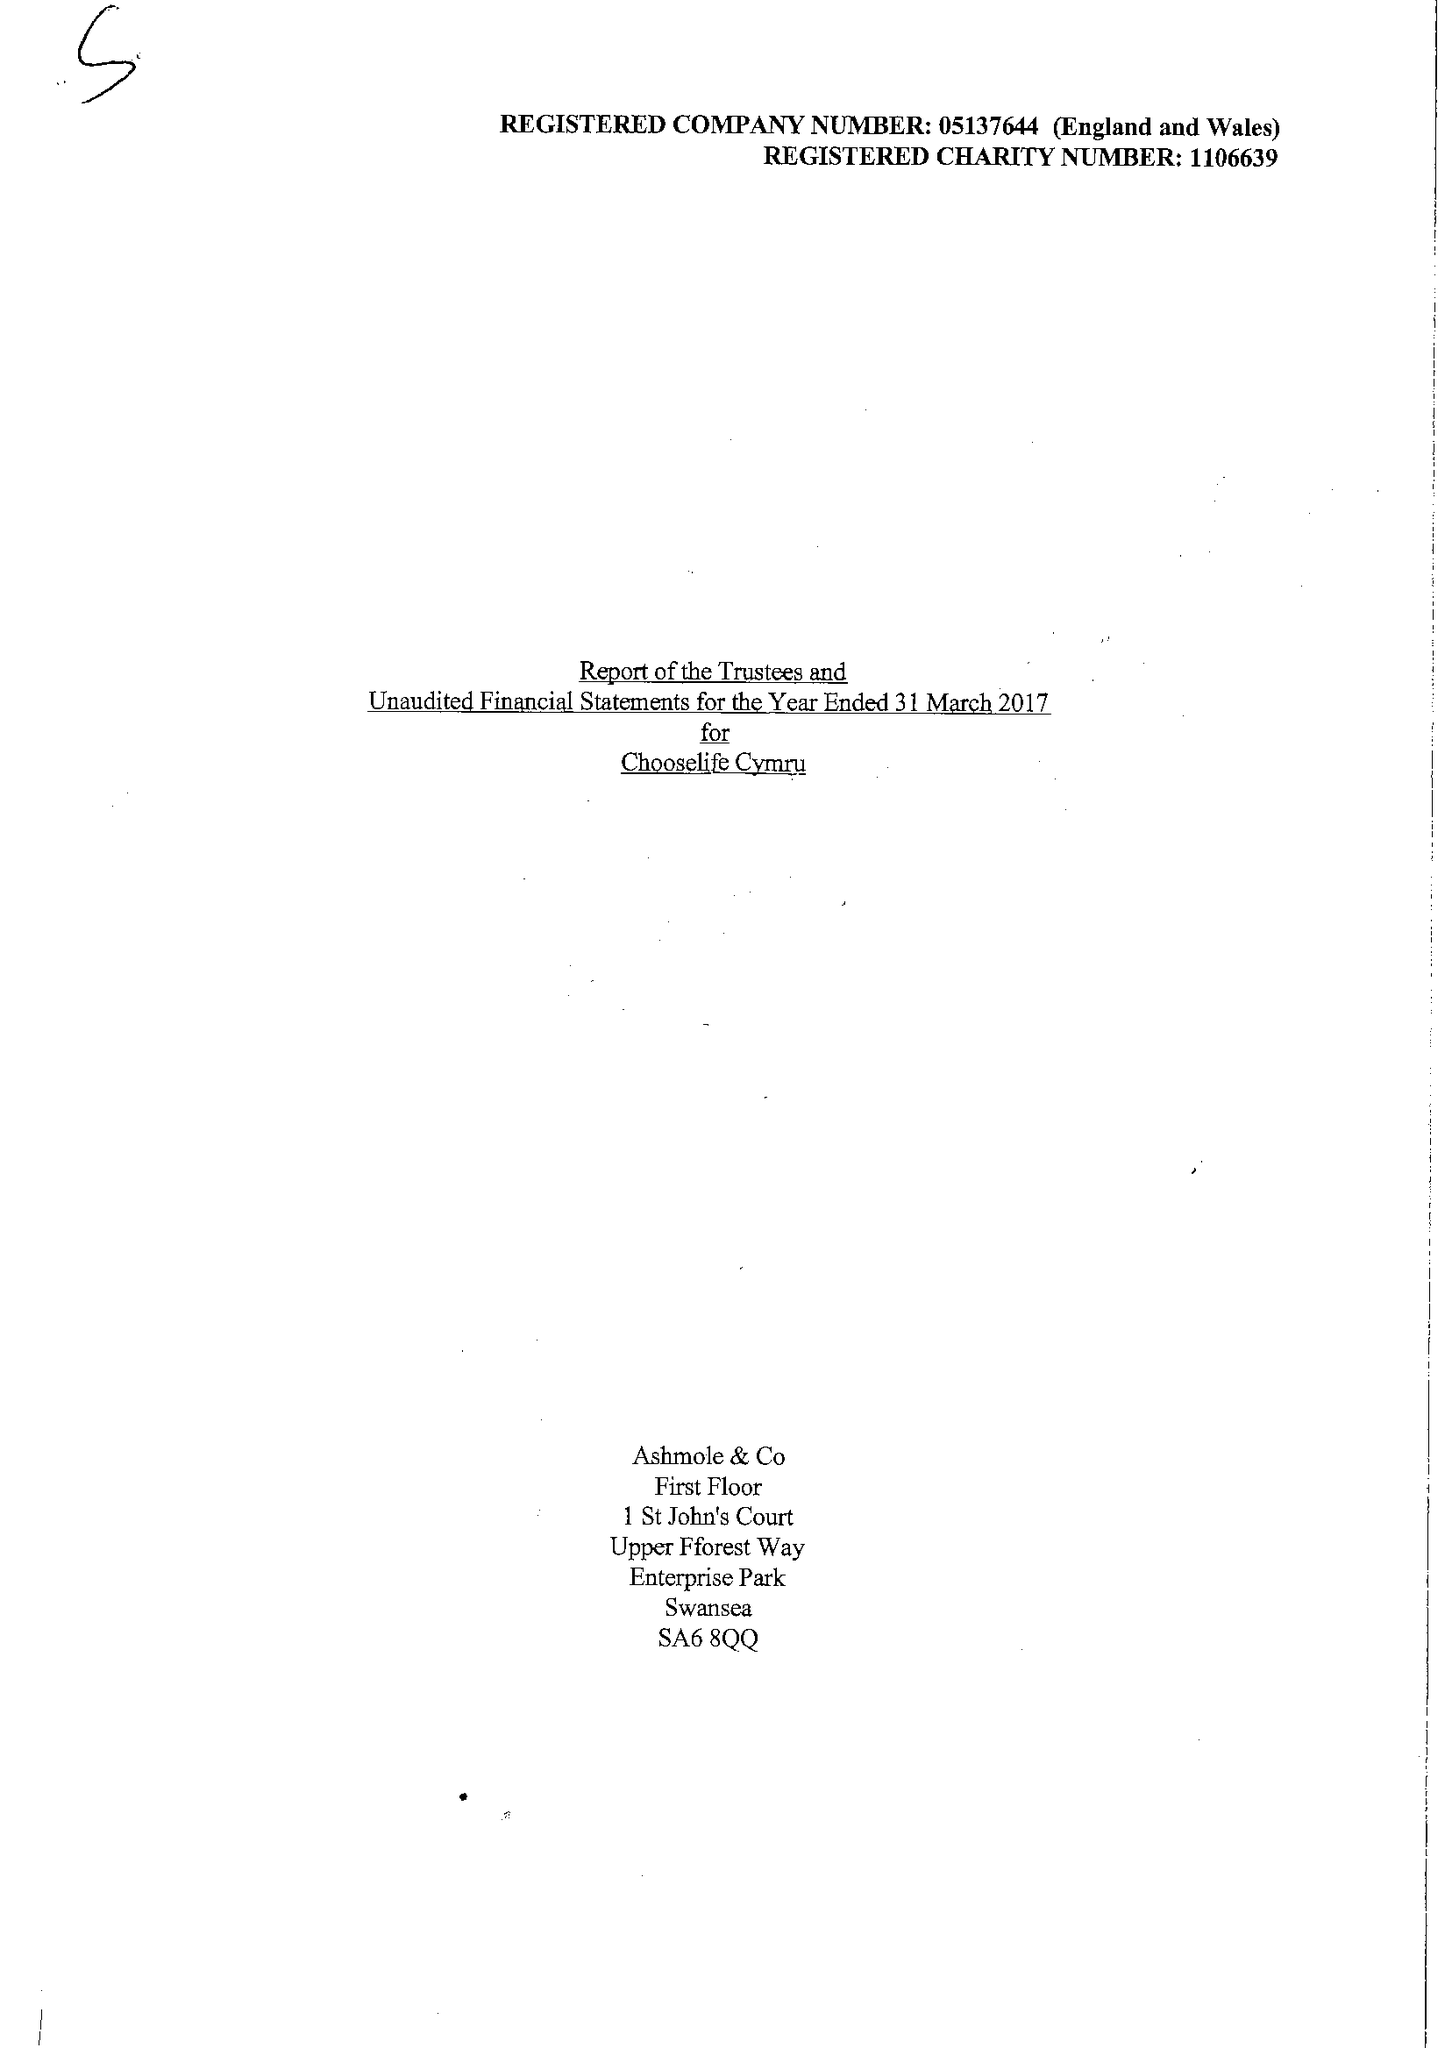What is the value for the address__postcode?
Answer the question using a single word or phrase. SA15 2NE 